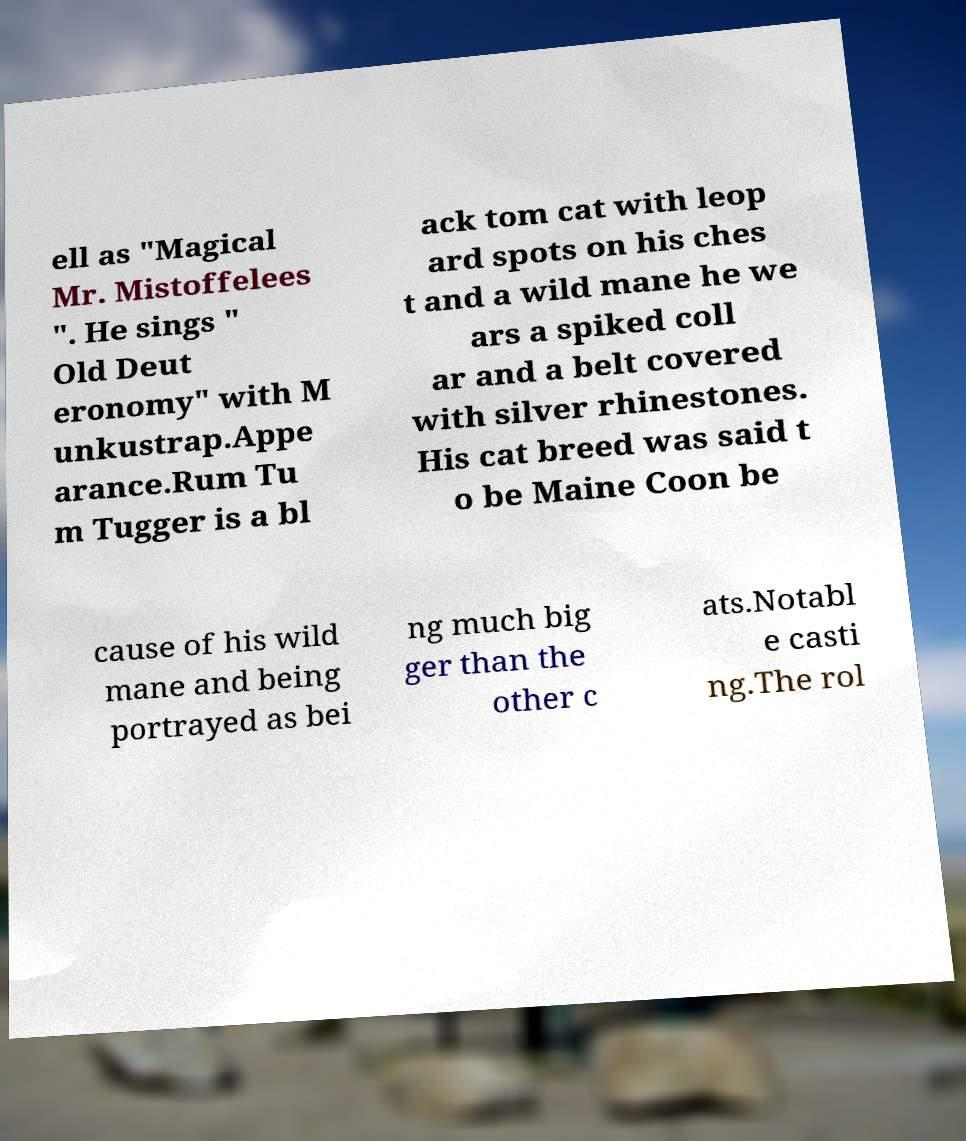Can you read and provide the text displayed in the image?This photo seems to have some interesting text. Can you extract and type it out for me? ell as "Magical Mr. Mistoffelees ". He sings " Old Deut eronomy" with M unkustrap.Appe arance.Rum Tu m Tugger is a bl ack tom cat with leop ard spots on his ches t and a wild mane he we ars a spiked coll ar and a belt covered with silver rhinestones. His cat breed was said t o be Maine Coon be cause of his wild mane and being portrayed as bei ng much big ger than the other c ats.Notabl e casti ng.The rol 